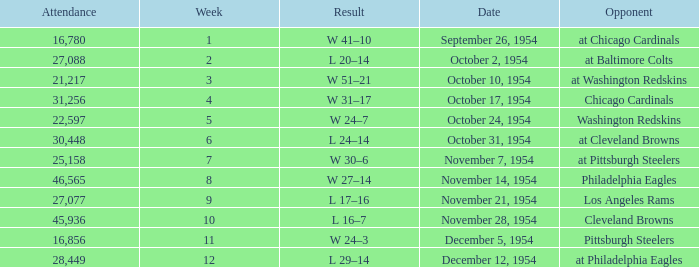How many weeks have october 31, 1954 as the date? 1.0. 